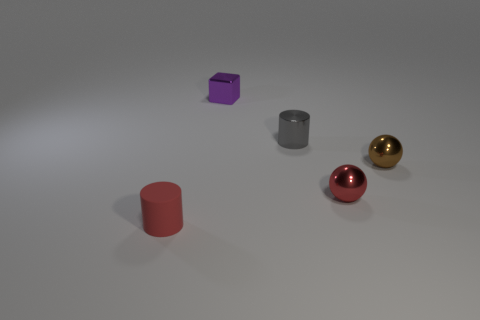There is a thing that is both behind the red sphere and to the left of the metal cylinder; what shape is it?
Your answer should be very brief. Cube. There is a cylinder that is right of the tiny red rubber thing; is its color the same as the matte cylinder?
Your answer should be very brief. No. There is a red object that is to the left of the tiny gray object; is it the same shape as the tiny red object that is to the right of the small shiny block?
Your response must be concise. No. There is a red object that is behind the tiny red cylinder; how big is it?
Offer a very short reply. Small. There is a red object that is behind the cylinder in front of the gray object; how big is it?
Your response must be concise. Small. Are there more yellow cylinders than small brown things?
Your answer should be very brief. No. Is the number of blocks that are behind the tiny block greater than the number of red matte things that are behind the brown metallic sphere?
Make the answer very short. No. What size is the thing that is both in front of the brown shiny sphere and right of the small gray cylinder?
Your answer should be compact. Small. What number of other objects are the same size as the brown metallic thing?
Provide a short and direct response. 4. There is a sphere that is the same color as the tiny rubber object; what is it made of?
Give a very brief answer. Metal. 